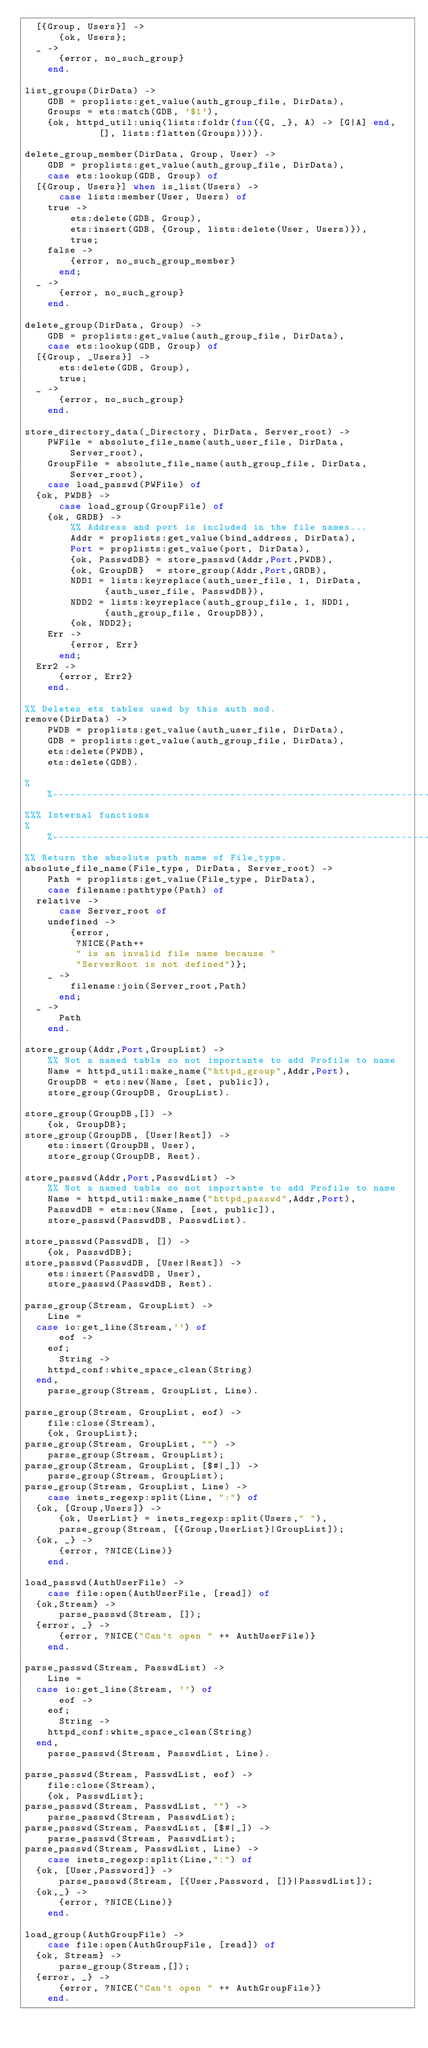Convert code to text. <code><loc_0><loc_0><loc_500><loc_500><_Erlang_>	[{Group, Users}] ->
	    {ok, Users};
	_ ->
	    {error, no_such_group}
    end.

list_groups(DirData) ->
    GDB = proplists:get_value(auth_group_file, DirData),
    Groups = ets:match(GDB, '$1'), 
    {ok, httpd_util:uniq(lists:foldr(fun({G, _}, A) -> [G|A] end,
				     [], lists:flatten(Groups)))}.

delete_group_member(DirData, Group, User) ->
    GDB = proplists:get_value(auth_group_file, DirData),
    case ets:lookup(GDB, Group) of
	[{Group, Users}] when is_list(Users) ->
	    case lists:member(User, Users) of
		true ->
		    ets:delete(GDB, Group),
		    ets:insert(GDB, {Group, lists:delete(User, Users)}),
		    true;
		false ->
		    {error, no_such_group_member}
	    end;
	_ ->
	    {error, no_such_group}
    end.

delete_group(DirData, Group) ->
    GDB = proplists:get_value(auth_group_file, DirData),
    case ets:lookup(GDB, Group) of
	[{Group, _Users}] ->
	    ets:delete(GDB, Group),
	    true;
	_ ->
	    {error, no_such_group}
    end.

store_directory_data(_Directory, DirData, Server_root) ->
    PWFile = absolute_file_name(auth_user_file, DirData, Server_root),
    GroupFile = absolute_file_name(auth_group_file, DirData, Server_root),
    case load_passwd(PWFile) of
	{ok, PWDB} ->
	    case load_group(GroupFile) of
		{ok, GRDB} ->
		    %% Address and port is included in the file names...
		    Addr = proplists:get_value(bind_address, DirData),
		    Port = proplists:get_value(port, DirData),
		    {ok, PasswdDB} = store_passwd(Addr,Port,PWDB),
		    {ok, GroupDB}  = store_group(Addr,Port,GRDB),
		    NDD1 = lists:keyreplace(auth_user_file, 1, DirData, 
					    {auth_user_file, PasswdDB}),
		    NDD2 = lists:keyreplace(auth_group_file, 1, NDD1, 
					    {auth_group_file, GroupDB}),
		    {ok, NDD2};
		Err ->
		    {error, Err}
	    end;
	Err2 ->
	    {error, Err2}
    end.

%% Deletes ets tables used by this auth mod.
remove(DirData) ->
    PWDB = proplists:get_value(auth_user_file, DirData),
    GDB = proplists:get_value(auth_group_file, DirData),
    ets:delete(PWDB),
    ets:delete(GDB).

%%--------------------------------------------------------------------
%%% Internal functions
%%--------------------------------------------------------------------
%% Return the absolute path name of File_type. 
absolute_file_name(File_type, DirData, Server_root) ->
    Path = proplists:get_value(File_type, DirData),
    case filename:pathtype(Path) of
	relative ->
	    case Server_root of
		undefined ->
		    {error,
		     ?NICE(Path++
			   " is an invalid file name because "
			   "ServerRoot is not defined")};
		_ ->
		    filename:join(Server_root,Path)
	    end;
	_ ->
	    Path
    end.

store_group(Addr,Port,GroupList) ->
    %% Not a named table so not importante to add Profile to name
    Name = httpd_util:make_name("httpd_group",Addr,Port),
    GroupDB = ets:new(Name, [set, public]),
    store_group(GroupDB, GroupList).

store_group(GroupDB,[]) ->
    {ok, GroupDB};
store_group(GroupDB, [User|Rest]) ->
    ets:insert(GroupDB, User),
    store_group(GroupDB, Rest).

store_passwd(Addr,Port,PasswdList) ->
    %% Not a named table so not importante to add Profile to name
    Name = httpd_util:make_name("httpd_passwd",Addr,Port),
    PasswdDB = ets:new(Name, [set, public]),
    store_passwd(PasswdDB, PasswdList).

store_passwd(PasswdDB, []) ->
    {ok, PasswdDB};
store_passwd(PasswdDB, [User|Rest]) ->
    ets:insert(PasswdDB, User),
    store_passwd(PasswdDB, Rest).

parse_group(Stream, GroupList) ->
    Line =
	case io:get_line(Stream,'') of
	    eof ->
		eof;
	    String ->
		httpd_conf:white_space_clean(String)
	end,
    parse_group(Stream, GroupList, Line).

parse_group(Stream, GroupList, eof) ->
    file:close(Stream),
    {ok, GroupList};
parse_group(Stream, GroupList, "") ->
    parse_group(Stream, GroupList);
parse_group(Stream, GroupList, [$#|_]) ->
    parse_group(Stream, GroupList);
parse_group(Stream, GroupList, Line) ->      
    case inets_regexp:split(Line, ":") of
	{ok, [Group,Users]} ->
	    {ok, UserList} = inets_regexp:split(Users," "),
	    parse_group(Stream, [{Group,UserList}|GroupList]);
	{ok, _} ->
	    {error, ?NICE(Line)}
    end.

load_passwd(AuthUserFile) ->
    case file:open(AuthUserFile, [read]) of
	{ok,Stream} ->
	    parse_passwd(Stream, []);
	{error, _} ->
	    {error, ?NICE("Can't open " ++ AuthUserFile)}
    end.

parse_passwd(Stream, PasswdList) ->
    Line =
	case io:get_line(Stream, '') of
	    eof ->
		eof;
	    String ->
		httpd_conf:white_space_clean(String)
	end,
    parse_passwd(Stream, PasswdList, Line).

parse_passwd(Stream, PasswdList, eof) ->
    file:close(Stream),
    {ok, PasswdList};
parse_passwd(Stream, PasswdList, "") ->
    parse_passwd(Stream, PasswdList);
parse_passwd(Stream, PasswdList, [$#|_]) ->
    parse_passwd(Stream, PasswdList);
parse_passwd(Stream, PasswdList, Line) ->      
    case inets_regexp:split(Line,":") of
	{ok, [User,Password]} ->
	    parse_passwd(Stream, [{User,Password, []}|PasswdList]);
	{ok,_} ->
	    {error, ?NICE(Line)}
    end.

load_group(AuthGroupFile) ->
    case file:open(AuthGroupFile, [read]) of
	{ok, Stream} ->
	    parse_group(Stream,[]);
	{error, _} ->
	    {error, ?NICE("Can't open " ++ AuthGroupFile)}
    end.
</code> 